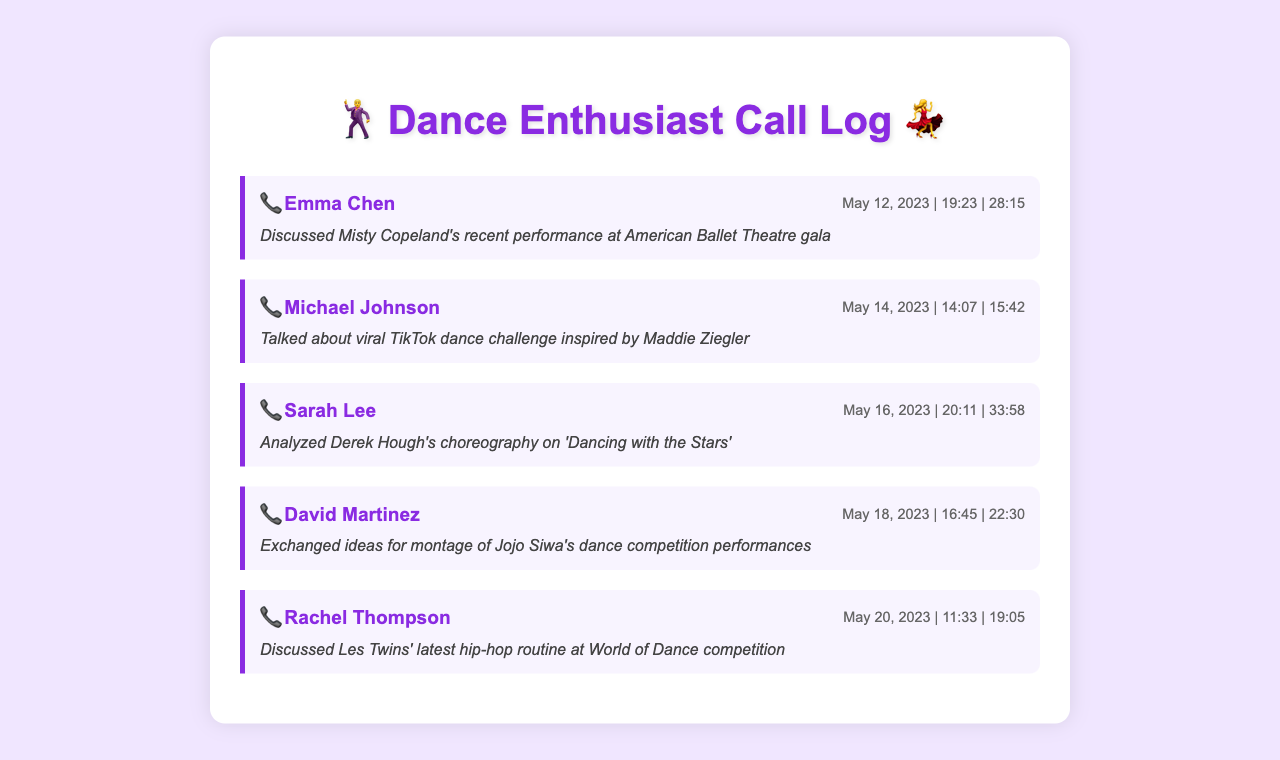what is the name of the first contact? The first contact in the call log is listed as Emma Chen.
Answer: Emma Chen how long was the call with Sarah Lee? The call duration with Sarah Lee was 33 minutes and 58 seconds.
Answer: 33:58 which dance professional's performance was discussed on May 12, 2023? The call on May 12 discussed Misty Copeland's performance.
Answer: Misty Copeland how many calls were made in total? There are five call records listed in the document.
Answer: 5 what trend did Michael Johnson talk about? Michael Johnson discussed a viral TikTok dance challenge inspired by Maddie Ziegler.
Answer: TikTok dance challenge who is discussed in the call on May 20, 2023? The call on May 20 discussed Les Twins' hip-hop routine.
Answer: Les Twins what is the theme of David Martinez's call? David Martinez's call exchanged ideas for a montage of Jojo Siwa's performances.
Answer: Montage of Jojo Siwa what type of performances are mentioned in the calls? The calls mention various dance performances from ballet to hip-hop.
Answer: Dance performances when did the call about 'Dancing with the Stars' take place? The call discussing 'Dancing with the Stars' took place on May 16, 2023.
Answer: May 16, 2023 